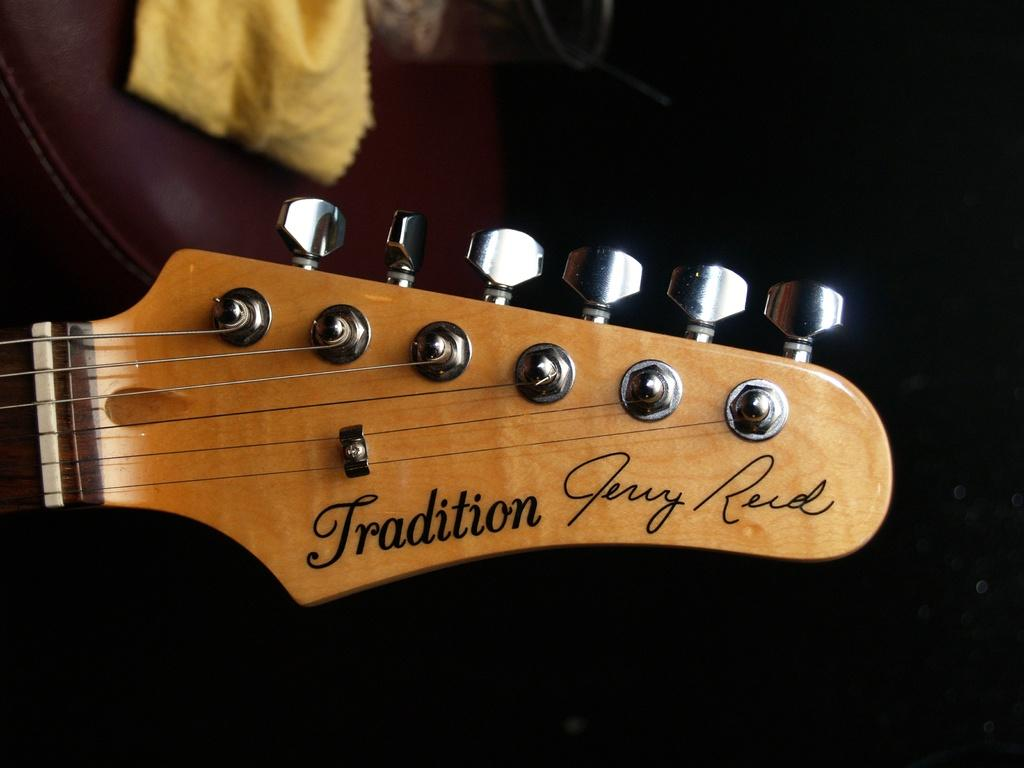What musical instrument is represented in the image? There is a part of a guitar in the image. What colors can be seen on the guitar part? The guitar part is brown and silver in color. What is the color of the brown-colored object in the image? The brown-colored object in the image is not specified, but it is mentioned that there is a brown-colored object present. What color is the cloth in the image? The cloth in the image is yellow in color. How would you describe the lighting in the image? The background of the image is dark. Is the guitar part in motion in the image? The guitar part is not in motion in the image; it is stationary. Can you see any yard or outdoor space in the image? There is no mention of a yard or outdoor space in the image; it only describes the objects and colors present. 